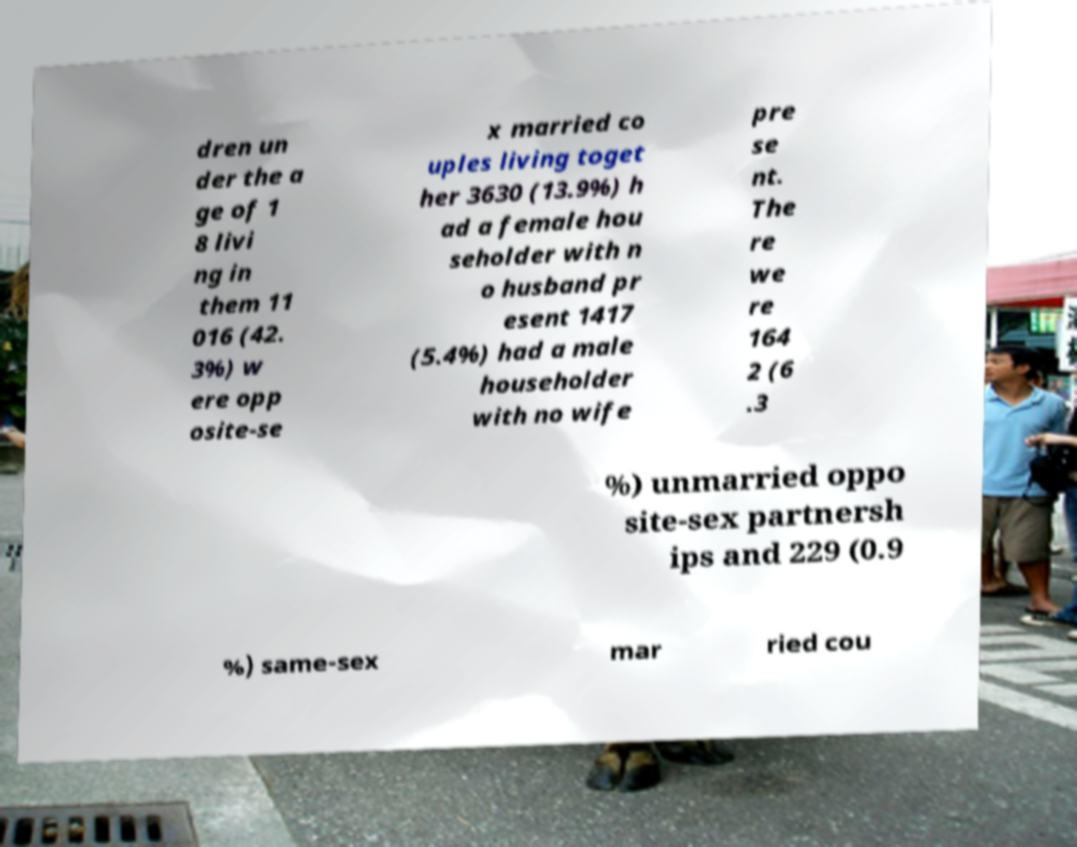Can you read and provide the text displayed in the image?This photo seems to have some interesting text. Can you extract and type it out for me? dren un der the a ge of 1 8 livi ng in them 11 016 (42. 3%) w ere opp osite-se x married co uples living toget her 3630 (13.9%) h ad a female hou seholder with n o husband pr esent 1417 (5.4%) had a male householder with no wife pre se nt. The re we re 164 2 (6 .3 %) unmarried oppo site-sex partnersh ips and 229 (0.9 %) same-sex mar ried cou 